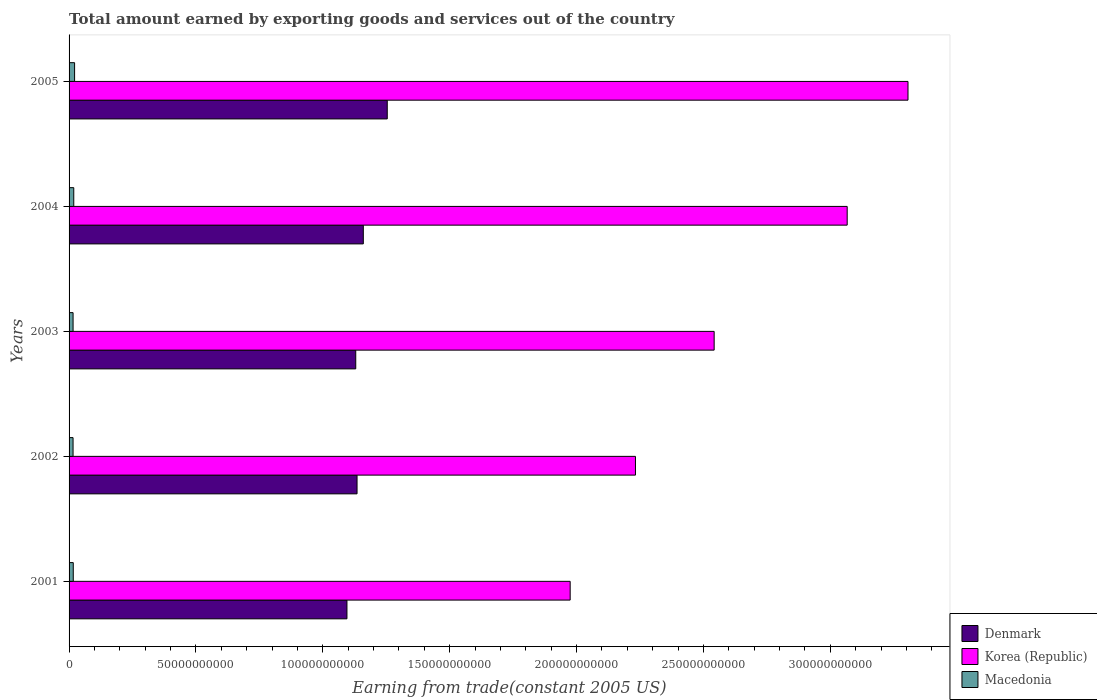How many groups of bars are there?
Offer a terse response. 5. Are the number of bars per tick equal to the number of legend labels?
Your response must be concise. Yes. How many bars are there on the 4th tick from the top?
Your answer should be very brief. 3. What is the label of the 3rd group of bars from the top?
Provide a short and direct response. 2003. What is the total amount earned by exporting goods and services in Denmark in 2003?
Your answer should be compact. 1.13e+11. Across all years, what is the maximum total amount earned by exporting goods and services in Denmark?
Ensure brevity in your answer.  1.25e+11. Across all years, what is the minimum total amount earned by exporting goods and services in Macedonia?
Your answer should be very brief. 1.57e+09. In which year was the total amount earned by exporting goods and services in Macedonia maximum?
Ensure brevity in your answer.  2005. In which year was the total amount earned by exporting goods and services in Macedonia minimum?
Provide a succinct answer. 2002. What is the total total amount earned by exporting goods and services in Macedonia in the graph?
Keep it short and to the point. 8.82e+09. What is the difference between the total amount earned by exporting goods and services in Denmark in 2002 and that in 2005?
Your answer should be very brief. -1.19e+1. What is the difference between the total amount earned by exporting goods and services in Denmark in 2005 and the total amount earned by exporting goods and services in Macedonia in 2002?
Ensure brevity in your answer.  1.24e+11. What is the average total amount earned by exporting goods and services in Korea (Republic) per year?
Offer a terse response. 2.62e+11. In the year 2005, what is the difference between the total amount earned by exporting goods and services in Denmark and total amount earned by exporting goods and services in Macedonia?
Ensure brevity in your answer.  1.23e+11. In how many years, is the total amount earned by exporting goods and services in Denmark greater than 160000000000 US$?
Offer a terse response. 0. What is the ratio of the total amount earned by exporting goods and services in Korea (Republic) in 2002 to that in 2003?
Give a very brief answer. 0.88. What is the difference between the highest and the second highest total amount earned by exporting goods and services in Korea (Republic)?
Your answer should be compact. 2.40e+1. What is the difference between the highest and the lowest total amount earned by exporting goods and services in Korea (Republic)?
Provide a succinct answer. 1.33e+11. In how many years, is the total amount earned by exporting goods and services in Denmark greater than the average total amount earned by exporting goods and services in Denmark taken over all years?
Offer a very short reply. 2. Is the sum of the total amount earned by exporting goods and services in Denmark in 2004 and 2005 greater than the maximum total amount earned by exporting goods and services in Korea (Republic) across all years?
Offer a very short reply. No. What is the difference between two consecutive major ticks on the X-axis?
Your answer should be compact. 5.00e+1. Does the graph contain any zero values?
Keep it short and to the point. No. Does the graph contain grids?
Your answer should be compact. No. How many legend labels are there?
Provide a succinct answer. 3. What is the title of the graph?
Ensure brevity in your answer.  Total amount earned by exporting goods and services out of the country. What is the label or title of the X-axis?
Offer a terse response. Earning from trade(constant 2005 US). What is the Earning from trade(constant 2005 US) of Denmark in 2001?
Give a very brief answer. 1.10e+11. What is the Earning from trade(constant 2005 US) of Korea (Republic) in 2001?
Ensure brevity in your answer.  1.97e+11. What is the Earning from trade(constant 2005 US) of Macedonia in 2001?
Your answer should be compact. 1.65e+09. What is the Earning from trade(constant 2005 US) in Denmark in 2002?
Offer a very short reply. 1.13e+11. What is the Earning from trade(constant 2005 US) in Korea (Republic) in 2002?
Provide a succinct answer. 2.23e+11. What is the Earning from trade(constant 2005 US) of Macedonia in 2002?
Ensure brevity in your answer.  1.57e+09. What is the Earning from trade(constant 2005 US) of Denmark in 2003?
Ensure brevity in your answer.  1.13e+11. What is the Earning from trade(constant 2005 US) in Korea (Republic) in 2003?
Keep it short and to the point. 2.54e+11. What is the Earning from trade(constant 2005 US) of Macedonia in 2003?
Offer a very short reply. 1.58e+09. What is the Earning from trade(constant 2005 US) in Denmark in 2004?
Offer a terse response. 1.16e+11. What is the Earning from trade(constant 2005 US) of Korea (Republic) in 2004?
Give a very brief answer. 3.07e+11. What is the Earning from trade(constant 2005 US) of Macedonia in 2004?
Offer a very short reply. 1.85e+09. What is the Earning from trade(constant 2005 US) in Denmark in 2005?
Your answer should be very brief. 1.25e+11. What is the Earning from trade(constant 2005 US) of Korea (Republic) in 2005?
Give a very brief answer. 3.31e+11. What is the Earning from trade(constant 2005 US) in Macedonia in 2005?
Ensure brevity in your answer.  2.18e+09. Across all years, what is the maximum Earning from trade(constant 2005 US) of Denmark?
Provide a short and direct response. 1.25e+11. Across all years, what is the maximum Earning from trade(constant 2005 US) of Korea (Republic)?
Offer a terse response. 3.31e+11. Across all years, what is the maximum Earning from trade(constant 2005 US) in Macedonia?
Provide a short and direct response. 2.18e+09. Across all years, what is the minimum Earning from trade(constant 2005 US) of Denmark?
Your answer should be very brief. 1.10e+11. Across all years, what is the minimum Earning from trade(constant 2005 US) of Korea (Republic)?
Offer a very short reply. 1.97e+11. Across all years, what is the minimum Earning from trade(constant 2005 US) in Macedonia?
Provide a short and direct response. 1.57e+09. What is the total Earning from trade(constant 2005 US) in Denmark in the graph?
Provide a short and direct response. 5.77e+11. What is the total Earning from trade(constant 2005 US) of Korea (Republic) in the graph?
Your answer should be compact. 1.31e+12. What is the total Earning from trade(constant 2005 US) in Macedonia in the graph?
Ensure brevity in your answer.  8.82e+09. What is the difference between the Earning from trade(constant 2005 US) of Denmark in 2001 and that in 2002?
Make the answer very short. -3.98e+09. What is the difference between the Earning from trade(constant 2005 US) of Korea (Republic) in 2001 and that in 2002?
Offer a terse response. -2.57e+1. What is the difference between the Earning from trade(constant 2005 US) in Macedonia in 2001 and that in 2002?
Give a very brief answer. 8.03e+07. What is the difference between the Earning from trade(constant 2005 US) in Denmark in 2001 and that in 2003?
Provide a succinct answer. -3.47e+09. What is the difference between the Earning from trade(constant 2005 US) in Korea (Republic) in 2001 and that in 2003?
Make the answer very short. -5.67e+1. What is the difference between the Earning from trade(constant 2005 US) in Macedonia in 2001 and that in 2003?
Offer a terse response. 7.50e+07. What is the difference between the Earning from trade(constant 2005 US) in Denmark in 2001 and that in 2004?
Keep it short and to the point. -6.45e+09. What is the difference between the Earning from trade(constant 2005 US) of Korea (Republic) in 2001 and that in 2004?
Provide a short and direct response. -1.09e+11. What is the difference between the Earning from trade(constant 2005 US) of Macedonia in 2001 and that in 2004?
Provide a short and direct response. -1.96e+08. What is the difference between the Earning from trade(constant 2005 US) in Denmark in 2001 and that in 2005?
Keep it short and to the point. -1.59e+1. What is the difference between the Earning from trade(constant 2005 US) in Korea (Republic) in 2001 and that in 2005?
Give a very brief answer. -1.33e+11. What is the difference between the Earning from trade(constant 2005 US) of Macedonia in 2001 and that in 2005?
Offer a very short reply. -5.27e+08. What is the difference between the Earning from trade(constant 2005 US) in Denmark in 2002 and that in 2003?
Offer a very short reply. 5.10e+08. What is the difference between the Earning from trade(constant 2005 US) of Korea (Republic) in 2002 and that in 2003?
Your response must be concise. -3.10e+1. What is the difference between the Earning from trade(constant 2005 US) of Macedonia in 2002 and that in 2003?
Your answer should be very brief. -5.26e+06. What is the difference between the Earning from trade(constant 2005 US) of Denmark in 2002 and that in 2004?
Keep it short and to the point. -2.47e+09. What is the difference between the Earning from trade(constant 2005 US) of Korea (Republic) in 2002 and that in 2004?
Ensure brevity in your answer.  -8.34e+1. What is the difference between the Earning from trade(constant 2005 US) in Macedonia in 2002 and that in 2004?
Provide a short and direct response. -2.76e+08. What is the difference between the Earning from trade(constant 2005 US) in Denmark in 2002 and that in 2005?
Keep it short and to the point. -1.19e+1. What is the difference between the Earning from trade(constant 2005 US) in Korea (Republic) in 2002 and that in 2005?
Your answer should be compact. -1.07e+11. What is the difference between the Earning from trade(constant 2005 US) in Macedonia in 2002 and that in 2005?
Provide a short and direct response. -6.07e+08. What is the difference between the Earning from trade(constant 2005 US) in Denmark in 2003 and that in 2004?
Make the answer very short. -2.98e+09. What is the difference between the Earning from trade(constant 2005 US) in Korea (Republic) in 2003 and that in 2004?
Provide a short and direct response. -5.24e+1. What is the difference between the Earning from trade(constant 2005 US) in Macedonia in 2003 and that in 2004?
Ensure brevity in your answer.  -2.71e+08. What is the difference between the Earning from trade(constant 2005 US) of Denmark in 2003 and that in 2005?
Keep it short and to the point. -1.24e+1. What is the difference between the Earning from trade(constant 2005 US) in Korea (Republic) in 2003 and that in 2005?
Keep it short and to the point. -7.64e+1. What is the difference between the Earning from trade(constant 2005 US) of Macedonia in 2003 and that in 2005?
Provide a succinct answer. -6.02e+08. What is the difference between the Earning from trade(constant 2005 US) of Denmark in 2004 and that in 2005?
Ensure brevity in your answer.  -9.44e+09. What is the difference between the Earning from trade(constant 2005 US) in Korea (Republic) in 2004 and that in 2005?
Offer a terse response. -2.40e+1. What is the difference between the Earning from trade(constant 2005 US) of Macedonia in 2004 and that in 2005?
Make the answer very short. -3.31e+08. What is the difference between the Earning from trade(constant 2005 US) in Denmark in 2001 and the Earning from trade(constant 2005 US) in Korea (Republic) in 2002?
Make the answer very short. -1.14e+11. What is the difference between the Earning from trade(constant 2005 US) of Denmark in 2001 and the Earning from trade(constant 2005 US) of Macedonia in 2002?
Give a very brief answer. 1.08e+11. What is the difference between the Earning from trade(constant 2005 US) in Korea (Republic) in 2001 and the Earning from trade(constant 2005 US) in Macedonia in 2002?
Give a very brief answer. 1.96e+11. What is the difference between the Earning from trade(constant 2005 US) of Denmark in 2001 and the Earning from trade(constant 2005 US) of Korea (Republic) in 2003?
Offer a terse response. -1.45e+11. What is the difference between the Earning from trade(constant 2005 US) in Denmark in 2001 and the Earning from trade(constant 2005 US) in Macedonia in 2003?
Ensure brevity in your answer.  1.08e+11. What is the difference between the Earning from trade(constant 2005 US) in Korea (Republic) in 2001 and the Earning from trade(constant 2005 US) in Macedonia in 2003?
Ensure brevity in your answer.  1.96e+11. What is the difference between the Earning from trade(constant 2005 US) in Denmark in 2001 and the Earning from trade(constant 2005 US) in Korea (Republic) in 2004?
Your answer should be compact. -1.97e+11. What is the difference between the Earning from trade(constant 2005 US) of Denmark in 2001 and the Earning from trade(constant 2005 US) of Macedonia in 2004?
Offer a terse response. 1.08e+11. What is the difference between the Earning from trade(constant 2005 US) in Korea (Republic) in 2001 and the Earning from trade(constant 2005 US) in Macedonia in 2004?
Make the answer very short. 1.96e+11. What is the difference between the Earning from trade(constant 2005 US) of Denmark in 2001 and the Earning from trade(constant 2005 US) of Korea (Republic) in 2005?
Your answer should be compact. -2.21e+11. What is the difference between the Earning from trade(constant 2005 US) of Denmark in 2001 and the Earning from trade(constant 2005 US) of Macedonia in 2005?
Your answer should be very brief. 1.07e+11. What is the difference between the Earning from trade(constant 2005 US) in Korea (Republic) in 2001 and the Earning from trade(constant 2005 US) in Macedonia in 2005?
Your answer should be compact. 1.95e+11. What is the difference between the Earning from trade(constant 2005 US) of Denmark in 2002 and the Earning from trade(constant 2005 US) of Korea (Republic) in 2003?
Ensure brevity in your answer.  -1.41e+11. What is the difference between the Earning from trade(constant 2005 US) of Denmark in 2002 and the Earning from trade(constant 2005 US) of Macedonia in 2003?
Provide a short and direct response. 1.12e+11. What is the difference between the Earning from trade(constant 2005 US) in Korea (Republic) in 2002 and the Earning from trade(constant 2005 US) in Macedonia in 2003?
Your response must be concise. 2.22e+11. What is the difference between the Earning from trade(constant 2005 US) in Denmark in 2002 and the Earning from trade(constant 2005 US) in Korea (Republic) in 2004?
Offer a very short reply. -1.93e+11. What is the difference between the Earning from trade(constant 2005 US) of Denmark in 2002 and the Earning from trade(constant 2005 US) of Macedonia in 2004?
Offer a very short reply. 1.12e+11. What is the difference between the Earning from trade(constant 2005 US) of Korea (Republic) in 2002 and the Earning from trade(constant 2005 US) of Macedonia in 2004?
Make the answer very short. 2.21e+11. What is the difference between the Earning from trade(constant 2005 US) of Denmark in 2002 and the Earning from trade(constant 2005 US) of Korea (Republic) in 2005?
Offer a terse response. -2.17e+11. What is the difference between the Earning from trade(constant 2005 US) in Denmark in 2002 and the Earning from trade(constant 2005 US) in Macedonia in 2005?
Your answer should be compact. 1.11e+11. What is the difference between the Earning from trade(constant 2005 US) in Korea (Republic) in 2002 and the Earning from trade(constant 2005 US) in Macedonia in 2005?
Provide a short and direct response. 2.21e+11. What is the difference between the Earning from trade(constant 2005 US) of Denmark in 2003 and the Earning from trade(constant 2005 US) of Korea (Republic) in 2004?
Offer a very short reply. -1.94e+11. What is the difference between the Earning from trade(constant 2005 US) in Denmark in 2003 and the Earning from trade(constant 2005 US) in Macedonia in 2004?
Provide a succinct answer. 1.11e+11. What is the difference between the Earning from trade(constant 2005 US) of Korea (Republic) in 2003 and the Earning from trade(constant 2005 US) of Macedonia in 2004?
Give a very brief answer. 2.52e+11. What is the difference between the Earning from trade(constant 2005 US) in Denmark in 2003 and the Earning from trade(constant 2005 US) in Korea (Republic) in 2005?
Your answer should be very brief. -2.18e+11. What is the difference between the Earning from trade(constant 2005 US) in Denmark in 2003 and the Earning from trade(constant 2005 US) in Macedonia in 2005?
Ensure brevity in your answer.  1.11e+11. What is the difference between the Earning from trade(constant 2005 US) in Korea (Republic) in 2003 and the Earning from trade(constant 2005 US) in Macedonia in 2005?
Your answer should be compact. 2.52e+11. What is the difference between the Earning from trade(constant 2005 US) of Denmark in 2004 and the Earning from trade(constant 2005 US) of Korea (Republic) in 2005?
Offer a terse response. -2.15e+11. What is the difference between the Earning from trade(constant 2005 US) in Denmark in 2004 and the Earning from trade(constant 2005 US) in Macedonia in 2005?
Your response must be concise. 1.14e+11. What is the difference between the Earning from trade(constant 2005 US) in Korea (Republic) in 2004 and the Earning from trade(constant 2005 US) in Macedonia in 2005?
Provide a short and direct response. 3.04e+11. What is the average Earning from trade(constant 2005 US) in Denmark per year?
Offer a terse response. 1.15e+11. What is the average Earning from trade(constant 2005 US) in Korea (Republic) per year?
Keep it short and to the point. 2.62e+11. What is the average Earning from trade(constant 2005 US) of Macedonia per year?
Offer a very short reply. 1.76e+09. In the year 2001, what is the difference between the Earning from trade(constant 2005 US) of Denmark and Earning from trade(constant 2005 US) of Korea (Republic)?
Ensure brevity in your answer.  -8.80e+1. In the year 2001, what is the difference between the Earning from trade(constant 2005 US) in Denmark and Earning from trade(constant 2005 US) in Macedonia?
Ensure brevity in your answer.  1.08e+11. In the year 2001, what is the difference between the Earning from trade(constant 2005 US) in Korea (Republic) and Earning from trade(constant 2005 US) in Macedonia?
Keep it short and to the point. 1.96e+11. In the year 2002, what is the difference between the Earning from trade(constant 2005 US) of Denmark and Earning from trade(constant 2005 US) of Korea (Republic)?
Provide a short and direct response. -1.10e+11. In the year 2002, what is the difference between the Earning from trade(constant 2005 US) in Denmark and Earning from trade(constant 2005 US) in Macedonia?
Give a very brief answer. 1.12e+11. In the year 2002, what is the difference between the Earning from trade(constant 2005 US) of Korea (Republic) and Earning from trade(constant 2005 US) of Macedonia?
Offer a very short reply. 2.22e+11. In the year 2003, what is the difference between the Earning from trade(constant 2005 US) in Denmark and Earning from trade(constant 2005 US) in Korea (Republic)?
Offer a terse response. -1.41e+11. In the year 2003, what is the difference between the Earning from trade(constant 2005 US) of Denmark and Earning from trade(constant 2005 US) of Macedonia?
Your response must be concise. 1.11e+11. In the year 2003, what is the difference between the Earning from trade(constant 2005 US) of Korea (Republic) and Earning from trade(constant 2005 US) of Macedonia?
Offer a very short reply. 2.53e+11. In the year 2004, what is the difference between the Earning from trade(constant 2005 US) in Denmark and Earning from trade(constant 2005 US) in Korea (Republic)?
Provide a short and direct response. -1.91e+11. In the year 2004, what is the difference between the Earning from trade(constant 2005 US) of Denmark and Earning from trade(constant 2005 US) of Macedonia?
Make the answer very short. 1.14e+11. In the year 2004, what is the difference between the Earning from trade(constant 2005 US) in Korea (Republic) and Earning from trade(constant 2005 US) in Macedonia?
Keep it short and to the point. 3.05e+11. In the year 2005, what is the difference between the Earning from trade(constant 2005 US) of Denmark and Earning from trade(constant 2005 US) of Korea (Republic)?
Offer a terse response. -2.05e+11. In the year 2005, what is the difference between the Earning from trade(constant 2005 US) of Denmark and Earning from trade(constant 2005 US) of Macedonia?
Provide a short and direct response. 1.23e+11. In the year 2005, what is the difference between the Earning from trade(constant 2005 US) of Korea (Republic) and Earning from trade(constant 2005 US) of Macedonia?
Ensure brevity in your answer.  3.28e+11. What is the ratio of the Earning from trade(constant 2005 US) in Denmark in 2001 to that in 2002?
Your response must be concise. 0.96. What is the ratio of the Earning from trade(constant 2005 US) of Korea (Republic) in 2001 to that in 2002?
Give a very brief answer. 0.88. What is the ratio of the Earning from trade(constant 2005 US) in Macedonia in 2001 to that in 2002?
Ensure brevity in your answer.  1.05. What is the ratio of the Earning from trade(constant 2005 US) of Denmark in 2001 to that in 2003?
Offer a very short reply. 0.97. What is the ratio of the Earning from trade(constant 2005 US) of Korea (Republic) in 2001 to that in 2003?
Offer a very short reply. 0.78. What is the ratio of the Earning from trade(constant 2005 US) of Macedonia in 2001 to that in 2003?
Ensure brevity in your answer.  1.05. What is the ratio of the Earning from trade(constant 2005 US) of Denmark in 2001 to that in 2004?
Keep it short and to the point. 0.94. What is the ratio of the Earning from trade(constant 2005 US) of Korea (Republic) in 2001 to that in 2004?
Offer a very short reply. 0.64. What is the ratio of the Earning from trade(constant 2005 US) of Macedonia in 2001 to that in 2004?
Keep it short and to the point. 0.89. What is the ratio of the Earning from trade(constant 2005 US) in Denmark in 2001 to that in 2005?
Your answer should be compact. 0.87. What is the ratio of the Earning from trade(constant 2005 US) of Korea (Republic) in 2001 to that in 2005?
Offer a terse response. 0.6. What is the ratio of the Earning from trade(constant 2005 US) of Macedonia in 2001 to that in 2005?
Your response must be concise. 0.76. What is the ratio of the Earning from trade(constant 2005 US) in Korea (Republic) in 2002 to that in 2003?
Your answer should be very brief. 0.88. What is the ratio of the Earning from trade(constant 2005 US) of Denmark in 2002 to that in 2004?
Give a very brief answer. 0.98. What is the ratio of the Earning from trade(constant 2005 US) in Korea (Republic) in 2002 to that in 2004?
Your response must be concise. 0.73. What is the ratio of the Earning from trade(constant 2005 US) of Macedonia in 2002 to that in 2004?
Give a very brief answer. 0.85. What is the ratio of the Earning from trade(constant 2005 US) of Denmark in 2002 to that in 2005?
Offer a terse response. 0.91. What is the ratio of the Earning from trade(constant 2005 US) of Korea (Republic) in 2002 to that in 2005?
Your answer should be very brief. 0.68. What is the ratio of the Earning from trade(constant 2005 US) of Macedonia in 2002 to that in 2005?
Offer a very short reply. 0.72. What is the ratio of the Earning from trade(constant 2005 US) of Denmark in 2003 to that in 2004?
Your answer should be very brief. 0.97. What is the ratio of the Earning from trade(constant 2005 US) in Korea (Republic) in 2003 to that in 2004?
Make the answer very short. 0.83. What is the ratio of the Earning from trade(constant 2005 US) in Macedonia in 2003 to that in 2004?
Keep it short and to the point. 0.85. What is the ratio of the Earning from trade(constant 2005 US) of Denmark in 2003 to that in 2005?
Offer a terse response. 0.9. What is the ratio of the Earning from trade(constant 2005 US) of Korea (Republic) in 2003 to that in 2005?
Offer a very short reply. 0.77. What is the ratio of the Earning from trade(constant 2005 US) of Macedonia in 2003 to that in 2005?
Offer a terse response. 0.72. What is the ratio of the Earning from trade(constant 2005 US) of Denmark in 2004 to that in 2005?
Make the answer very short. 0.92. What is the ratio of the Earning from trade(constant 2005 US) in Korea (Republic) in 2004 to that in 2005?
Provide a succinct answer. 0.93. What is the ratio of the Earning from trade(constant 2005 US) in Macedonia in 2004 to that in 2005?
Provide a short and direct response. 0.85. What is the difference between the highest and the second highest Earning from trade(constant 2005 US) in Denmark?
Ensure brevity in your answer.  9.44e+09. What is the difference between the highest and the second highest Earning from trade(constant 2005 US) of Korea (Republic)?
Offer a terse response. 2.40e+1. What is the difference between the highest and the second highest Earning from trade(constant 2005 US) in Macedonia?
Offer a very short reply. 3.31e+08. What is the difference between the highest and the lowest Earning from trade(constant 2005 US) in Denmark?
Provide a succinct answer. 1.59e+1. What is the difference between the highest and the lowest Earning from trade(constant 2005 US) in Korea (Republic)?
Give a very brief answer. 1.33e+11. What is the difference between the highest and the lowest Earning from trade(constant 2005 US) in Macedonia?
Offer a very short reply. 6.07e+08. 